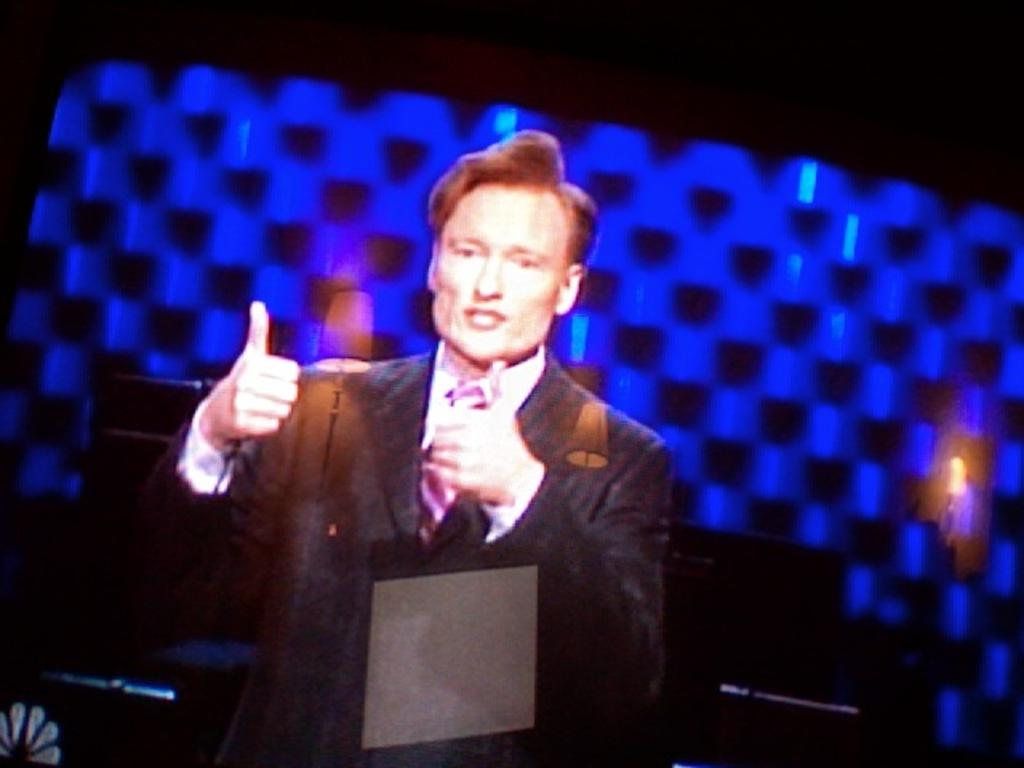Who is present in the image? There is a man in the image. What is the man doing in the image? The man is standing in the image. What is the man wearing in the image? The man is wearing a coat and a tie in the image. What is the color of the background in the image? The background of the image is blue. How many clovers can be seen growing in the image? There are no clovers present in the image. What type of frogs can be seen interacting with the man in the image? There are no frogs present in the image; the man is alone. 